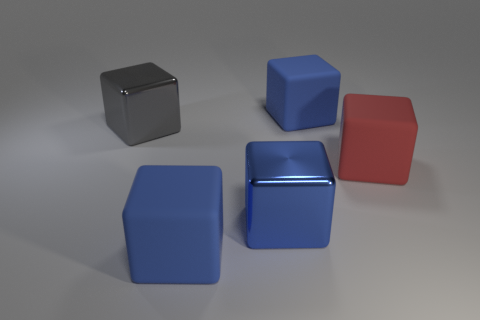Subtract all blue balls. How many blue blocks are left? 3 Subtract all red matte blocks. How many blocks are left? 4 Subtract all gray blocks. How many blocks are left? 4 Subtract all brown cubes. Subtract all cyan cylinders. How many cubes are left? 5 Add 2 gray metal things. How many objects exist? 7 Add 4 big metallic blocks. How many big metallic blocks are left? 6 Add 1 metallic blocks. How many metallic blocks exist? 3 Subtract 0 blue cylinders. How many objects are left? 5 Subtract all red rubber things. Subtract all red matte cubes. How many objects are left? 3 